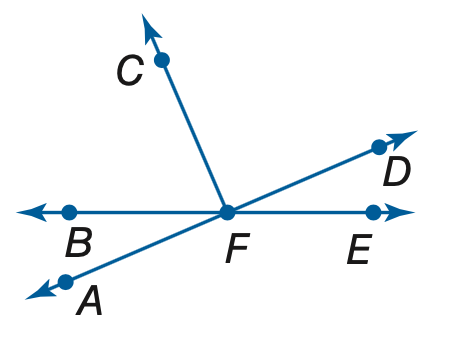Question: If m \angle A F B = 8 x - 6 and m \angle B F C = 14 x + 8, find the value of x so that \angle A F C is a right angle.
Choices:
A. 2
B. 3
C. 4
D. 5
Answer with the letter. Answer: C 